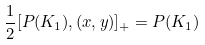<formula> <loc_0><loc_0><loc_500><loc_500>\frac { 1 } { 2 } [ P ( K _ { 1 } ) , ( x , y ) ] _ { + } = P ( K _ { 1 } )</formula> 